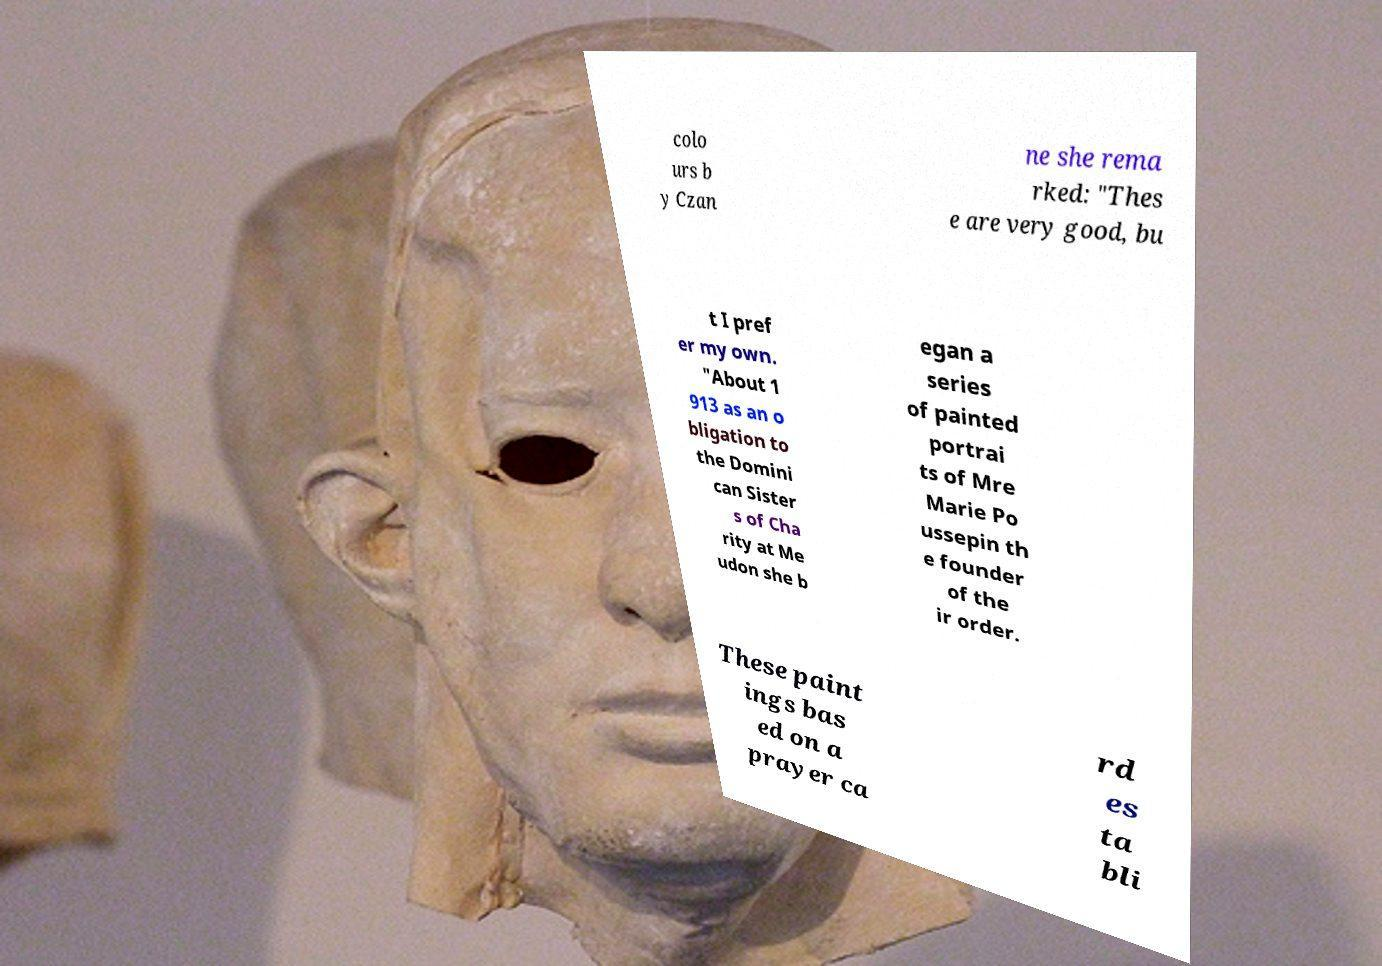There's text embedded in this image that I need extracted. Can you transcribe it verbatim? colo urs b y Czan ne she rema rked: "Thes e are very good, bu t I pref er my own. "About 1 913 as an o bligation to the Domini can Sister s of Cha rity at Me udon she b egan a series of painted portrai ts of Mre Marie Po ussepin th e founder of the ir order. These paint ings bas ed on a prayer ca rd es ta bli 